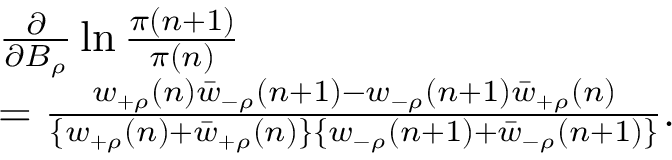Convert formula to latex. <formula><loc_0><loc_0><loc_500><loc_500>\begin{array} { r l } & { \frac { \partial } { \partial B _ { \rho } } \ln \frac { \pi ( n + 1 ) } { \pi ( n ) } \ } \\ & { = \frac { w _ { + \rho } ( n ) \bar { w } _ { - \rho } ( n + 1 ) - w _ { - \rho } ( n + 1 ) \bar { w } _ { + \rho } ( n ) } { \{ w _ { + \rho } ( n ) + \bar { w } _ { + \rho } ( n ) \} \{ w _ { - \rho } ( n + 1 ) + \bar { w } _ { - \rho } ( n + 1 ) \} } . } \end{array}</formula> 